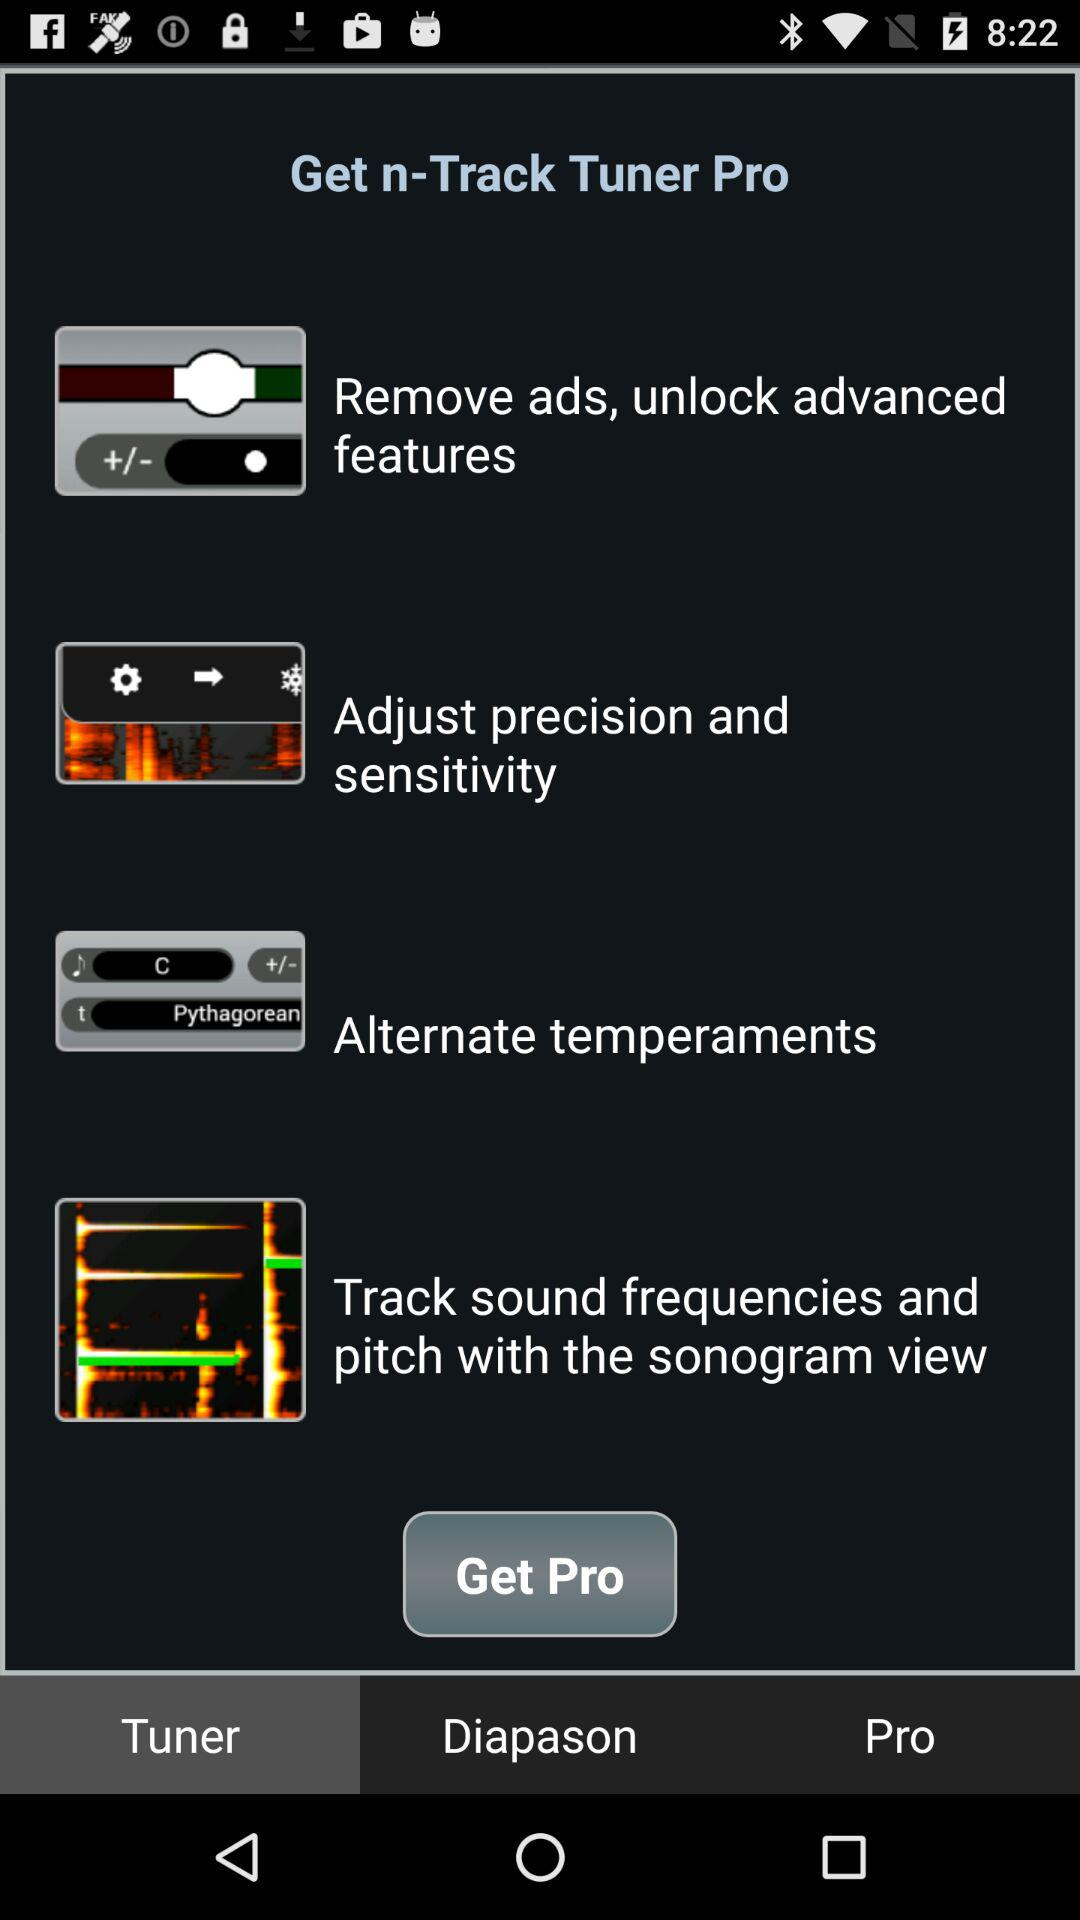Which tab is selected? The selected tab is "Tuner". 